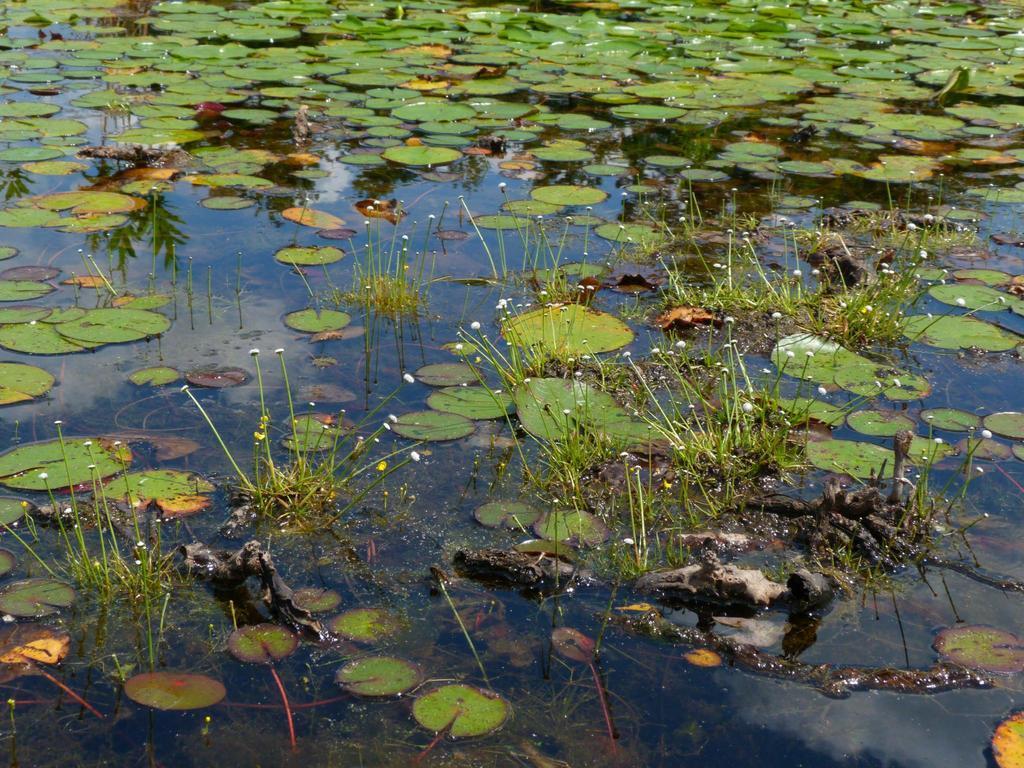Could you give a brief overview of what you see in this image? In this image I can see few flowers in white color, I can also see leaves on the water and the leaves are in green color. 